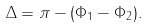Convert formula to latex. <formula><loc_0><loc_0><loc_500><loc_500>\Delta = \pi - ( \Phi _ { 1 } - \Phi _ { 2 } ) .</formula> 